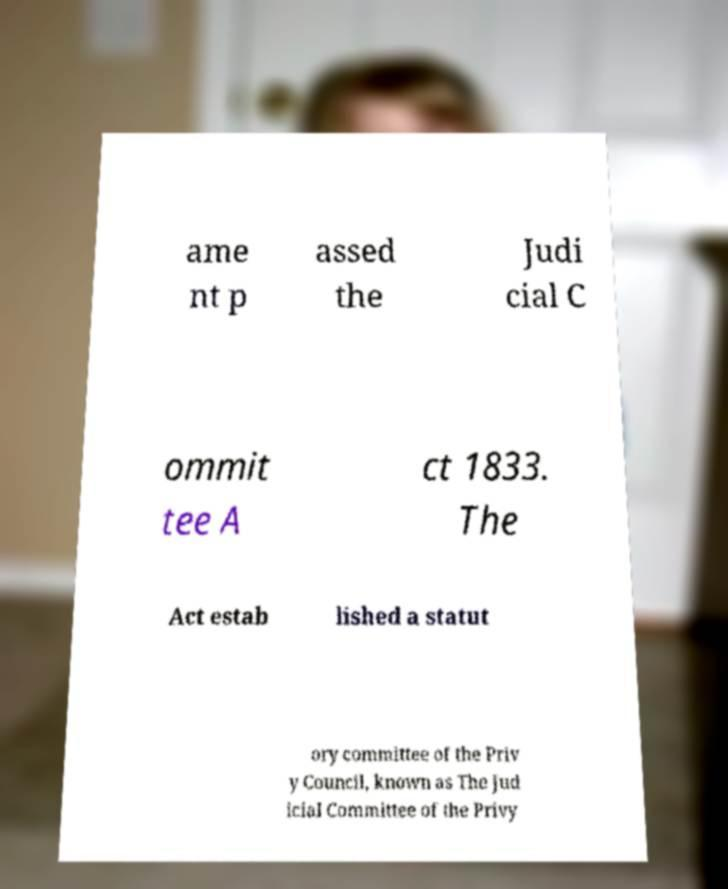Please read and relay the text visible in this image. What does it say? ame nt p assed the Judi cial C ommit tee A ct 1833. The Act estab lished a statut ory committee of the Priv y Council, known as The Jud icial Committee of the Privy 